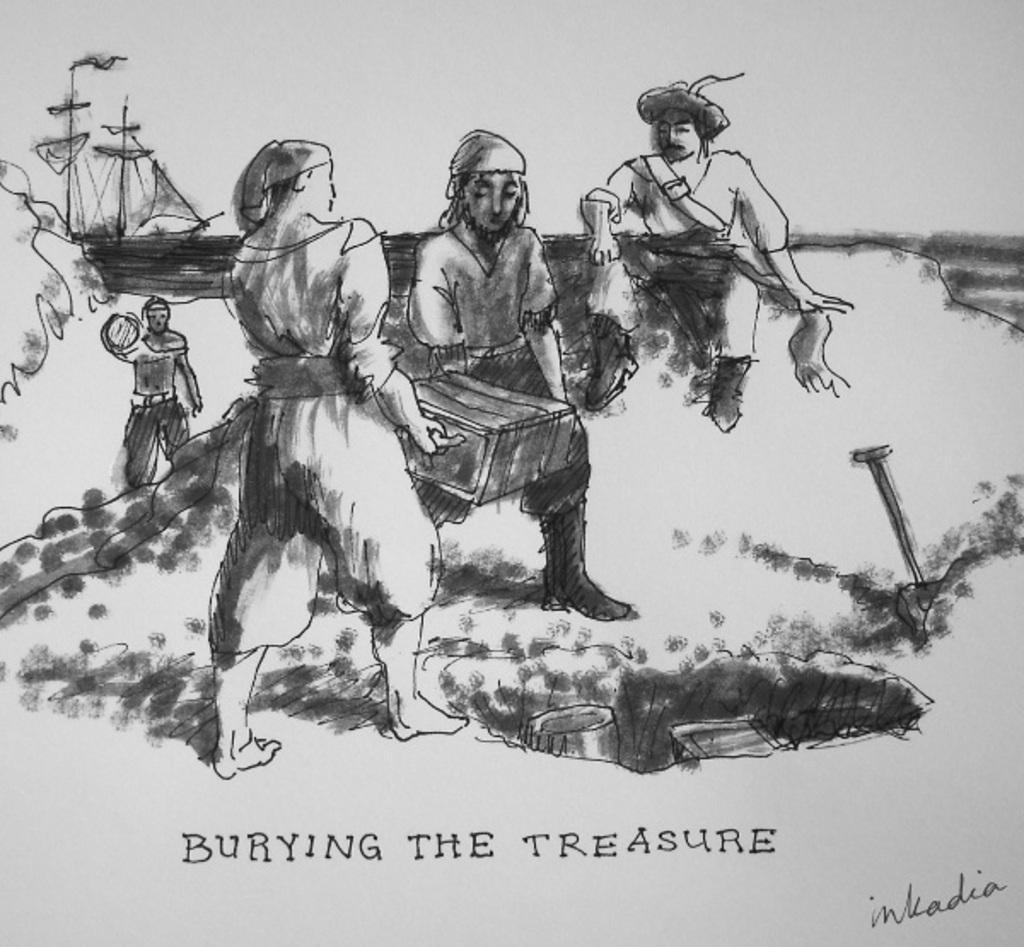Could you give a brief overview of what you see in this image? In this picture there is a painting of two persons standing and holding a box in their hands and there is another persons sitting beside them and there is another person standing in the left corner and there is burying the treasure written below the image. 